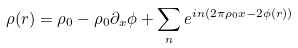<formula> <loc_0><loc_0><loc_500><loc_500>\rho ( r ) = \rho _ { 0 } - \rho _ { 0 } \partial _ { x } \phi + \sum _ { n } e ^ { i n ( 2 \pi \rho _ { 0 } x - 2 \phi ( r ) ) }</formula> 